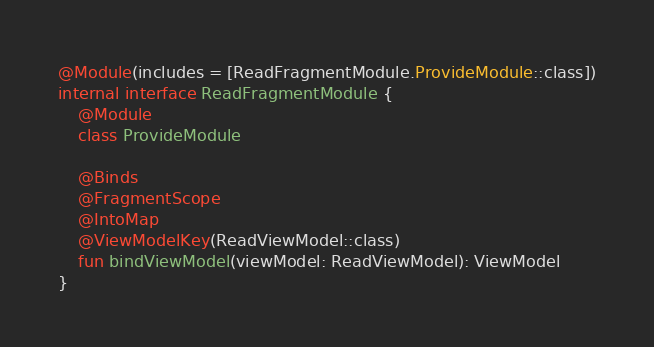<code> <loc_0><loc_0><loc_500><loc_500><_Kotlin_>@Module(includes = [ReadFragmentModule.ProvideModule::class])
internal interface ReadFragmentModule {
    @Module
    class ProvideModule

    @Binds
    @FragmentScope
    @IntoMap
    @ViewModelKey(ReadViewModel::class)
    fun bindViewModel(viewModel: ReadViewModel): ViewModel
}
</code> 